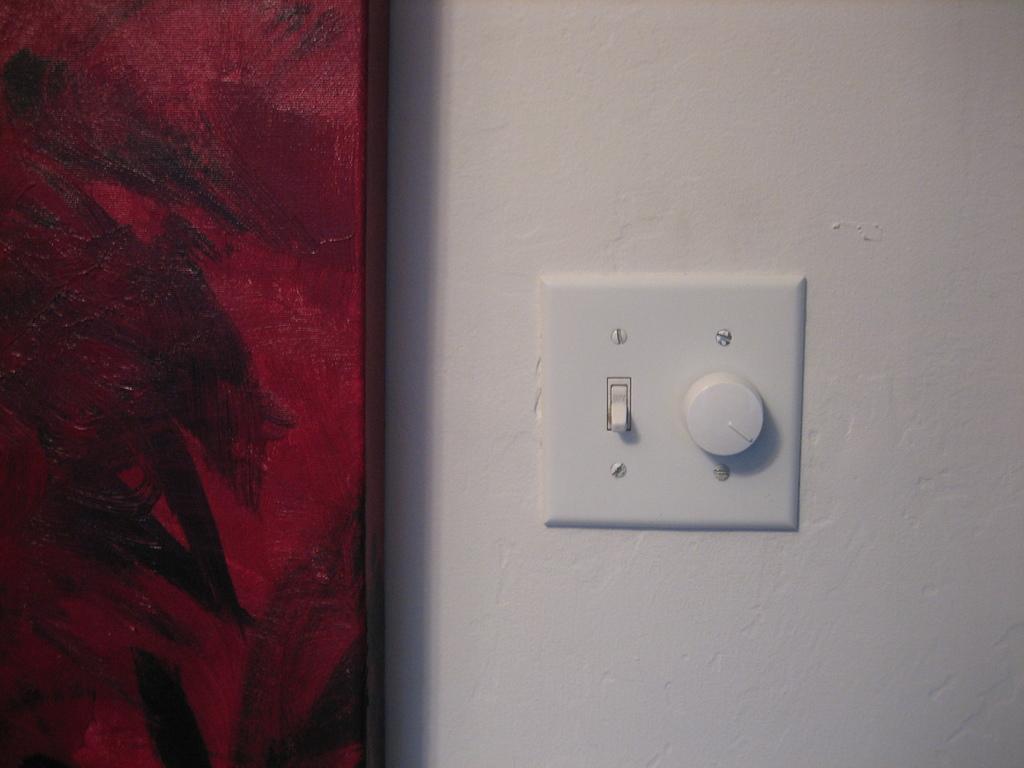Describe this image in one or two sentences. In this picture I can see a switch and a ceiling fan regulator on the wall and looks like a cupboard on the left side of the picture. 